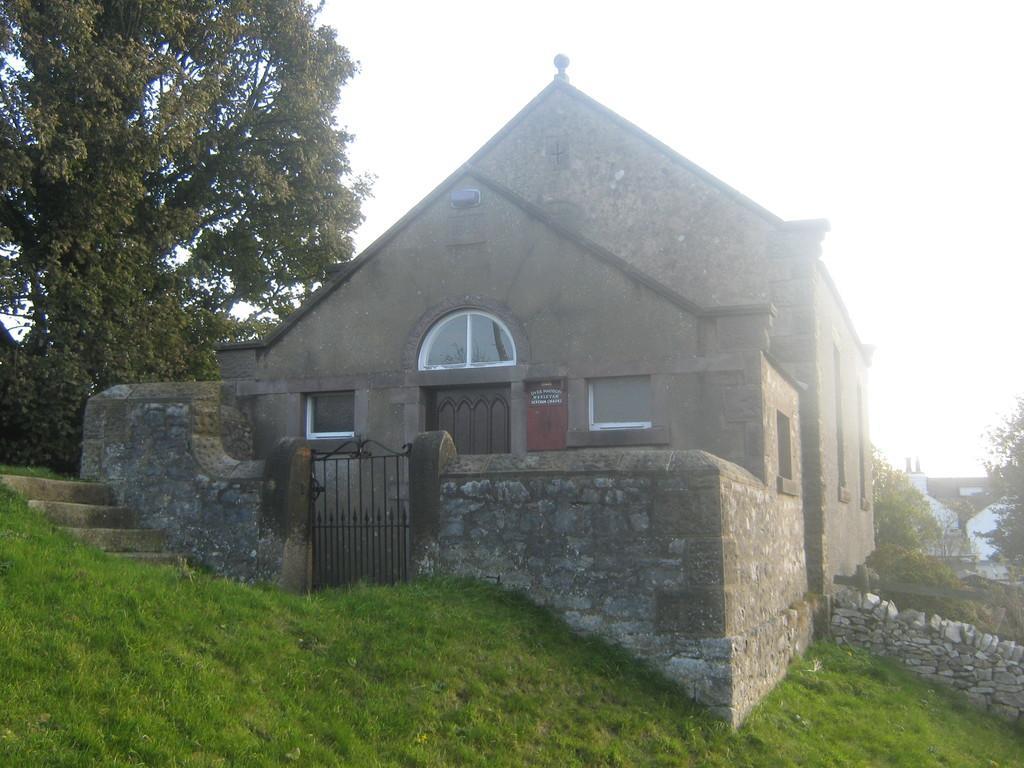How would you summarize this image in a sentence or two? In the center of the image there is a house. there is a door. there is a gate. At the bottom of the image there is grass. There are staircase. There is a tree. In the background of the image there is sky. 